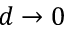<formula> <loc_0><loc_0><loc_500><loc_500>d \rightarrow 0</formula> 